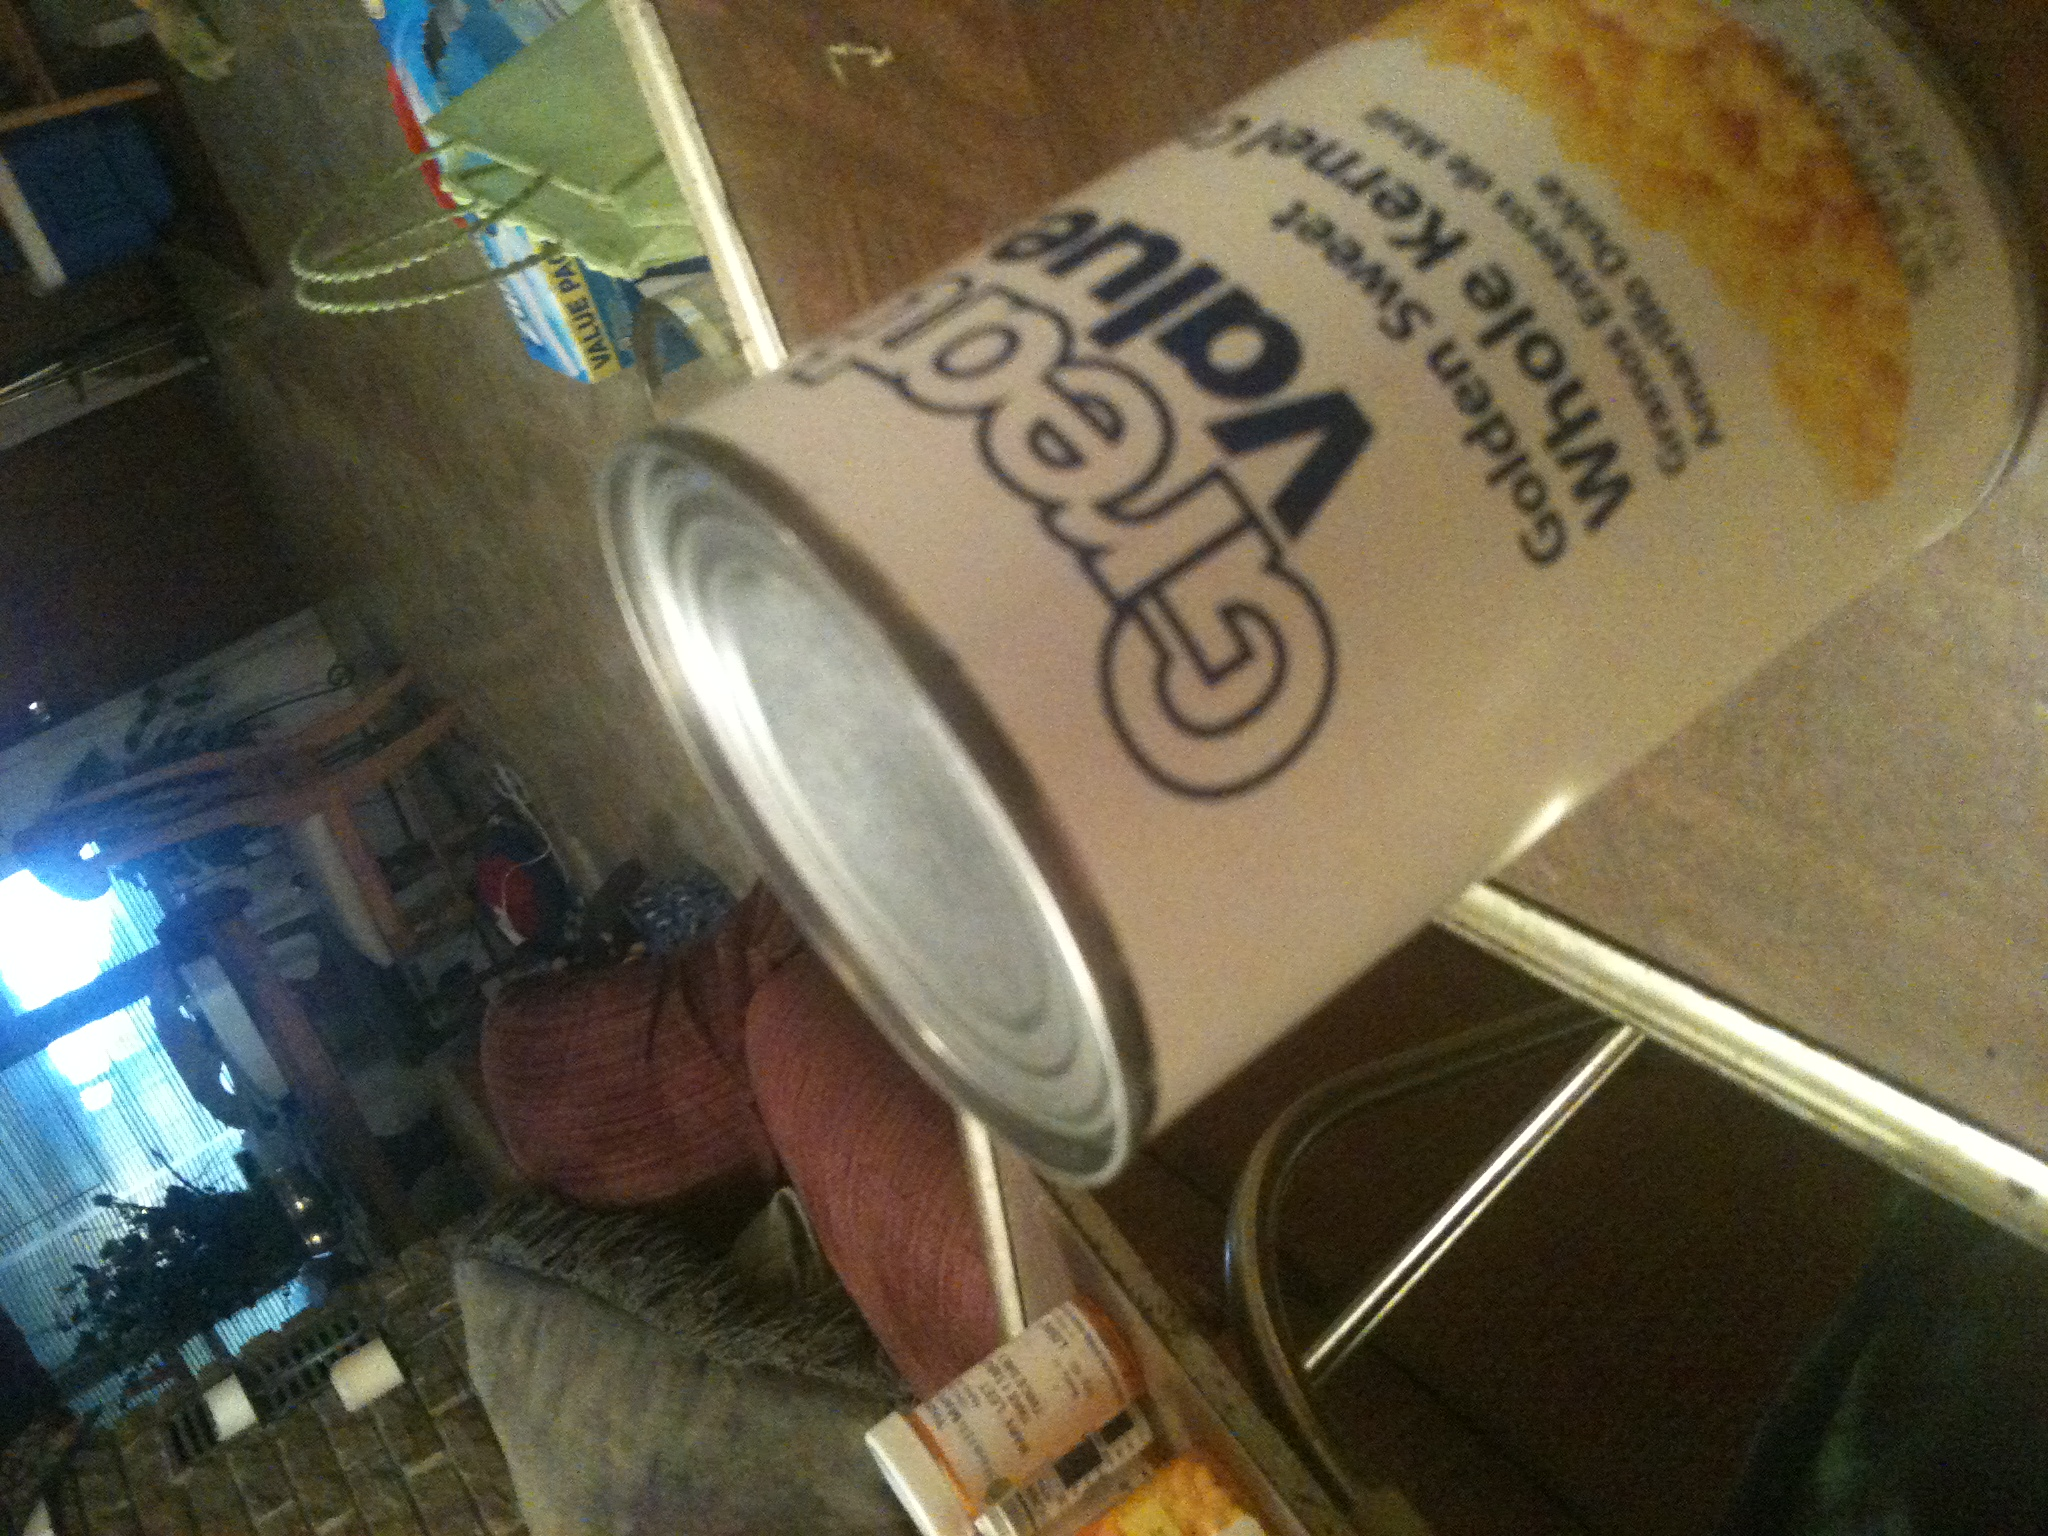What is in this can? The can contains golden sweet whole kernel corn, which is a type of sweet corn preserved in its naturally sugary and slightly savory state right after harvesting. This canned version is ideal for adding to salads, soups, and casseroles for extra flavor and nutrition. 